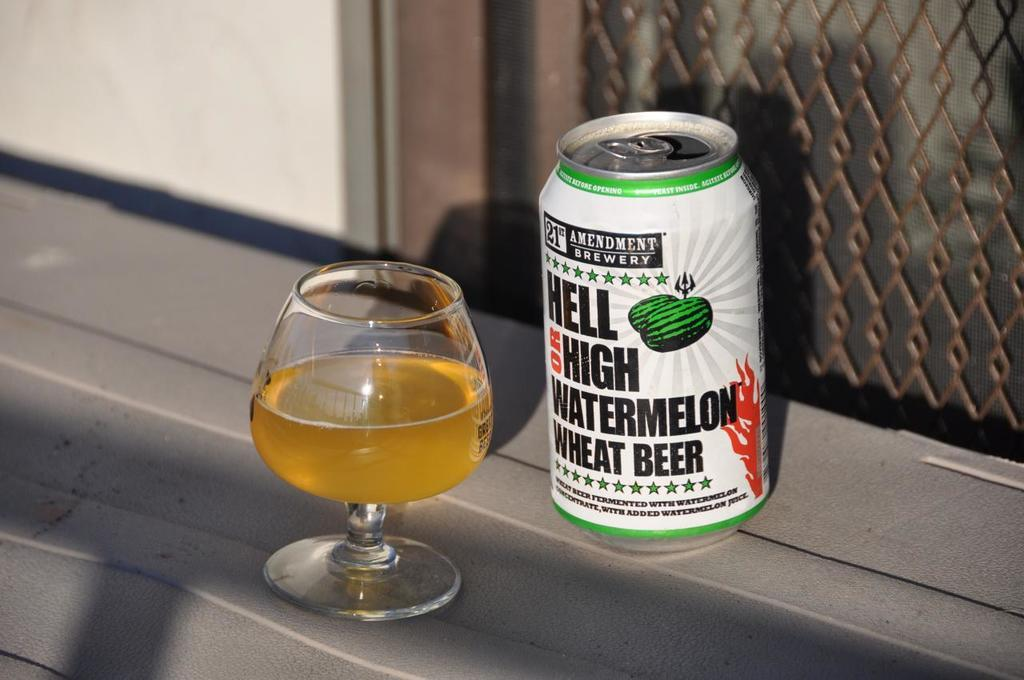<image>
Present a compact description of the photo's key features. Hell on high watermelon wheat beer can with a glass of beer 